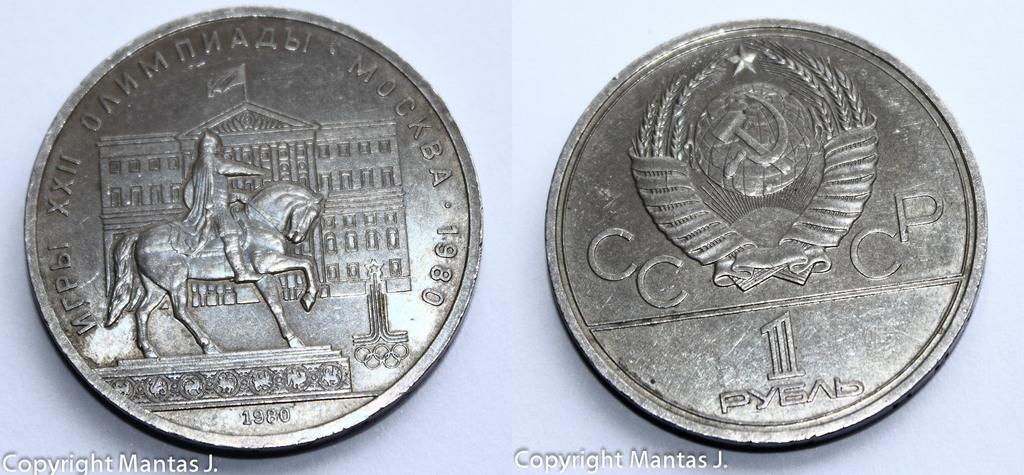<image>
Share a concise interpretation of the image provided. One side of the coin shows a horse with the year 1980. 